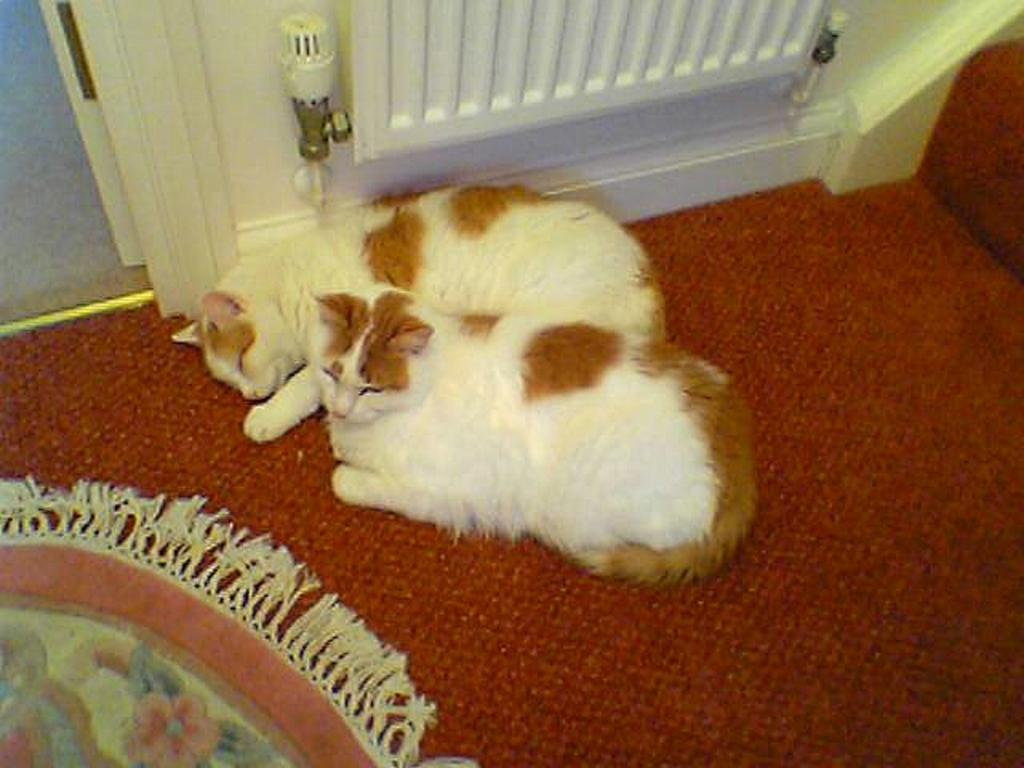What animals can be seen in the image? There are cats sleeping in the image. Where are the cats located in the image? The cats are on the floor. What is the position of the cats in the image? The cats are in the center of the image. What is on the floor in the image? There is a floor mat on the floor. What color is the wall in the image? The wall in the image is white in color. What type of stamp can be seen on the birthday cake in the image? There is no stamp or birthday cake present in the image; it features cats sleeping on a floor mat. What color is the yarn that the cats are playing with in the image? There is no yarn present in the image; the cats are sleeping on a floor mat. 